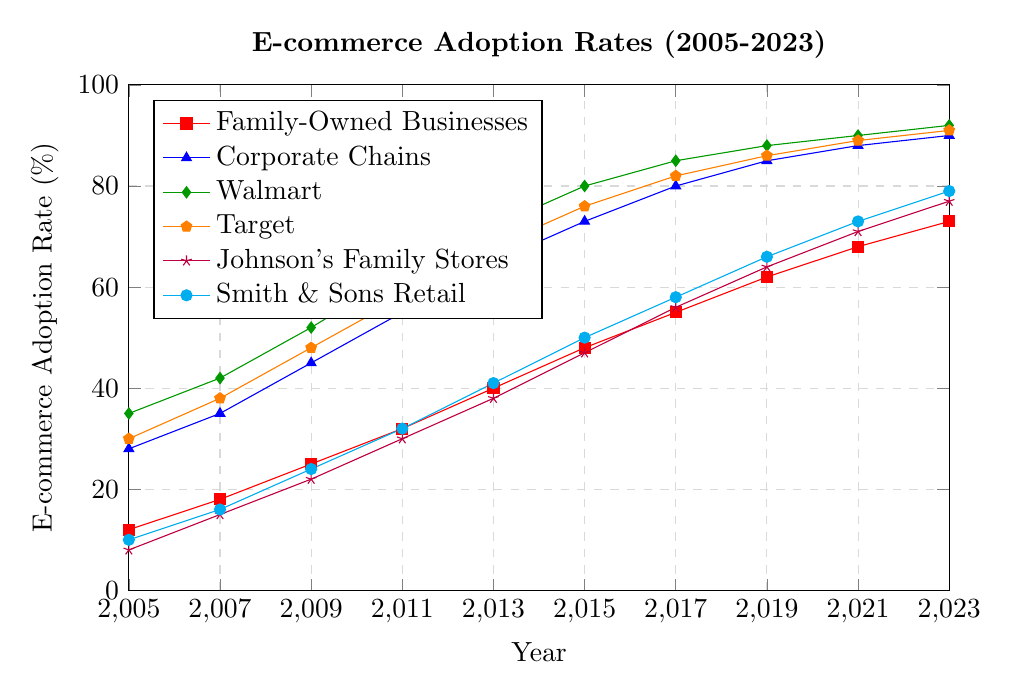What is the e-commerce adoption rate for family-owned businesses in 2023? Locate the data point for family-owned businesses on the x-axis at 2023, which corresponds to 73%.
Answer: 73% Which group had a higher e-commerce adoption rate in 2009, Walmart or Target? Examine the lines for Walmart and Target in 2009. Walmart's adoption rate is 52%, while Target's rate is 48%.
Answer: Walmart What was the difference in e-commerce adoption rates between corporate chains and family-owned businesses in 2011? The adoption rate for corporate chains in 2011 is 55%, and for family-owned businesses, it is 32%. The difference is 55% - 32% = 23%.
Answer: 23% What is the trend observed in the e-commerce adoption rates for Johnson's Family Stores from 2005 to 2023? Observe the line for Johnson's Family Stores from 2005 to 2023. The adoption rate increases steadily from 8% in 2005 to 77% in 2023.
Answer: Steady increase By looking at the plot, which group had the fastest rate of adoption from 2005 to 2023? Compare the slopes of all the lines from 2005 to 2023. Corporate chains and Walmart both show a rapid increase, but the steepest slope belongs to Corporate Chains as it starts at 28% and ends at 90%, a 62% increase.
Answer: Corporate Chains In what year did Smith & Sons Retail reach an e-commerce adoption rate of 50%? Trace the line for Smith & Sons Retail and find when it reaches 50%, which occurs in 2015.
Answer: 2015 How many years did it take for family-owned businesses to increase their e-commerce adoption rate from 32% to 55%? The adoption rate for family-owned businesses was 32% in 2011 and 55% in 2017. The time taken is 2017 - 2011 = 6 years.
Answer: 6 years What is the difference in the e-commerce adoption rate between the highest and lowest adopting groups in 2023? In 2023, the highest rate is Walmart at 92%, and the lowest is Family-Owned Businesses at 73%. The difference is 92% - 73% = 19%.
Answer: 19% Which specific family-owned store had the highest e-commerce adoption rate in 2009? Examine the data points for Johnson's Family Stores and Smith & Sons Retail in 2009. Johnson's Family Stores have a 22% rate, whereas Smith & Sons Retail is at 24%. Hence, Smith & Sons Retail had the highest rate in 2009 among these stores.
Answer: Smith & Sons Retail 